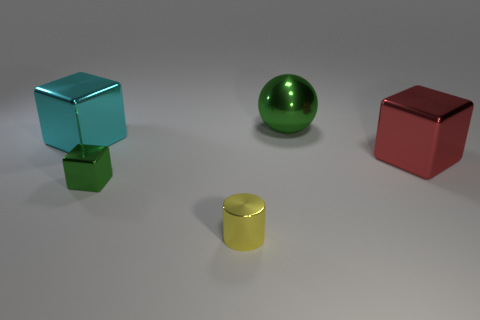Add 5 big gray things. How many objects exist? 10 Subtract all tiny metal cubes. How many cubes are left? 2 Subtract all cubes. How many objects are left? 2 Subtract 0 red balls. How many objects are left? 5 Subtract all tiny yellow things. Subtract all green metallic blocks. How many objects are left? 3 Add 4 tiny objects. How many tiny objects are left? 6 Add 1 yellow things. How many yellow things exist? 2 